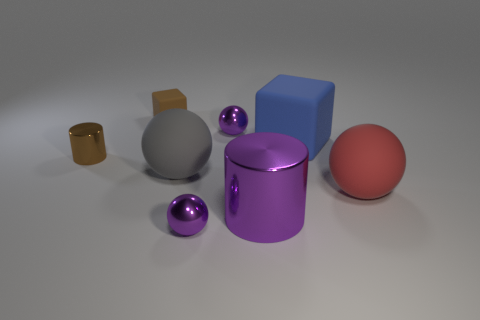Add 1 big cylinders. How many objects exist? 9 Subtract all blocks. How many objects are left? 6 Subtract 0 yellow cylinders. How many objects are left? 8 Subtract all brown matte objects. Subtract all small brown objects. How many objects are left? 5 Add 6 large gray matte things. How many large gray matte things are left? 7 Add 2 small spheres. How many small spheres exist? 4 